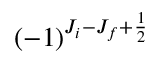Convert formula to latex. <formula><loc_0><loc_0><loc_500><loc_500>( - 1 ) ^ { J _ { i } - J _ { f } + \frac { 1 } { 2 } }</formula> 